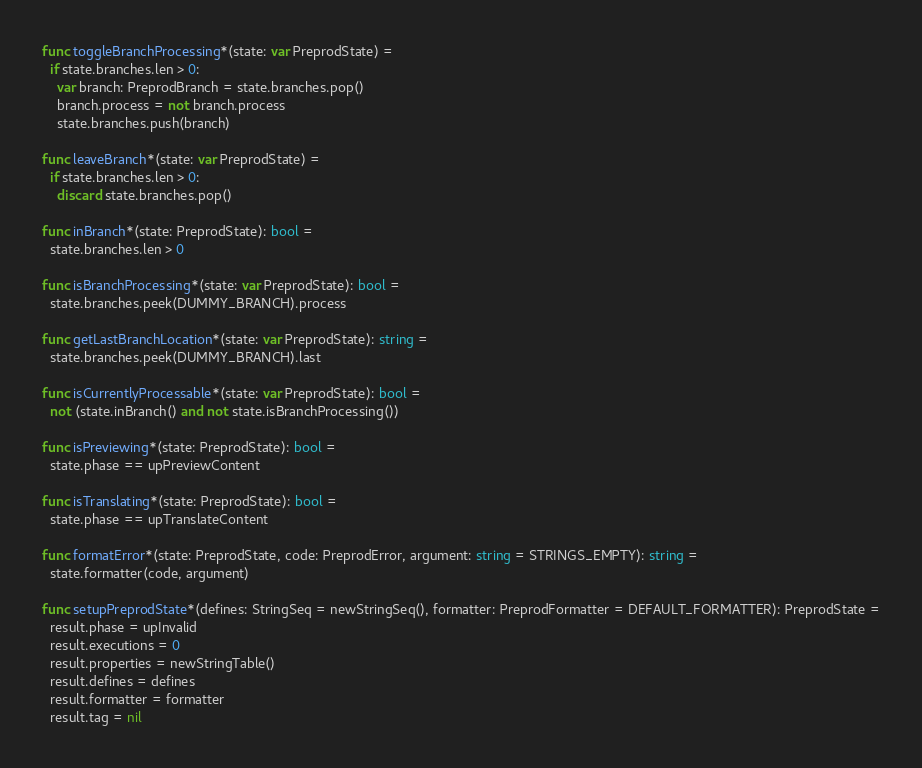Convert code to text. <code><loc_0><loc_0><loc_500><loc_500><_Nim_>func toggleBranchProcessing*(state: var PreprodState) =
  if state.branches.len > 0:
    var branch: PreprodBranch = state.branches.pop()
    branch.process = not branch.process
    state.branches.push(branch)

func leaveBranch*(state: var PreprodState) =
  if state.branches.len > 0:
    discard state.branches.pop()

func inBranch*(state: PreprodState): bool =
  state.branches.len > 0

func isBranchProcessing*(state: var PreprodState): bool =
  state.branches.peek(DUMMY_BRANCH).process

func getLastBranchLocation*(state: var PreprodState): string =
  state.branches.peek(DUMMY_BRANCH).last

func isCurrentlyProcessable*(state: var PreprodState): bool =
  not (state.inBranch() and not state.isBranchProcessing())

func isPreviewing*(state: PreprodState): bool =
  state.phase == upPreviewContent

func isTranslating*(state: PreprodState): bool =
  state.phase == upTranslateContent

func formatError*(state: PreprodState, code: PreprodError, argument: string = STRINGS_EMPTY): string =
  state.formatter(code, argument)

func setupPreprodState*(defines: StringSeq = newStringSeq(), formatter: PreprodFormatter = DEFAULT_FORMATTER): PreprodState =
  result.phase = upInvalid
  result.executions = 0
  result.properties = newStringTable()
  result.defines = defines
  result.formatter = formatter
  result.tag = nil
</code> 